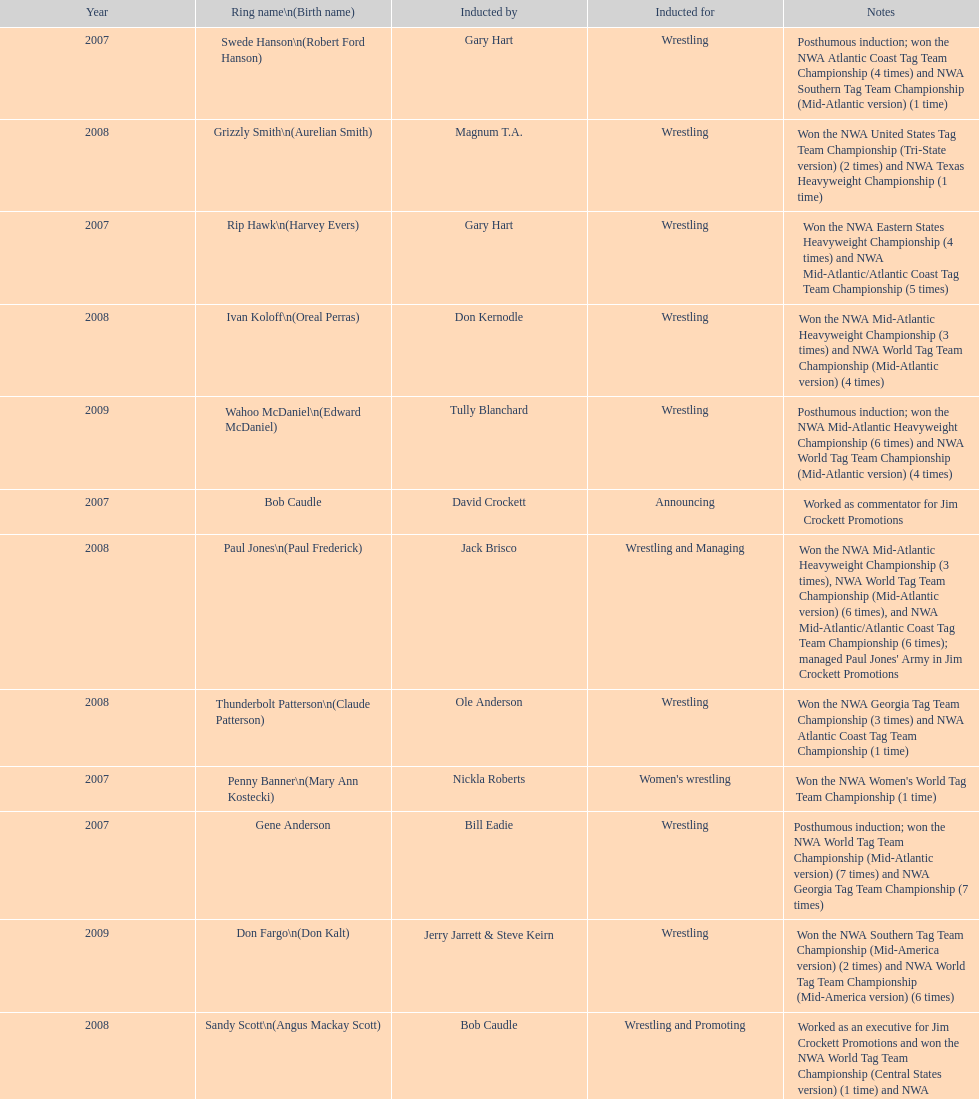Bob caudle was an announcer, who was the additional one? Lance Russell. 